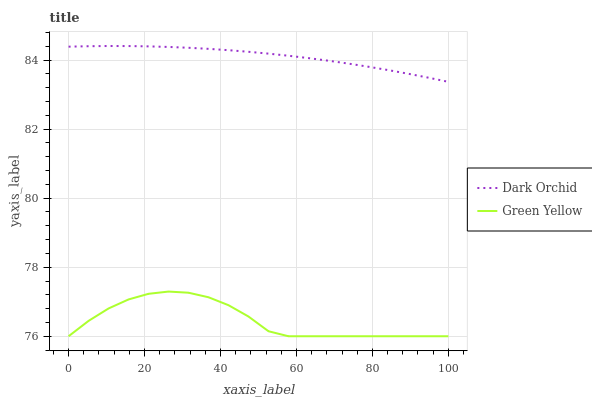Does Green Yellow have the minimum area under the curve?
Answer yes or no. Yes. Does Dark Orchid have the maximum area under the curve?
Answer yes or no. Yes. Does Dark Orchid have the minimum area under the curve?
Answer yes or no. No. Is Dark Orchid the smoothest?
Answer yes or no. Yes. Is Green Yellow the roughest?
Answer yes or no. Yes. Is Dark Orchid the roughest?
Answer yes or no. No. Does Green Yellow have the lowest value?
Answer yes or no. Yes. Does Dark Orchid have the lowest value?
Answer yes or no. No. Does Dark Orchid have the highest value?
Answer yes or no. Yes. Is Green Yellow less than Dark Orchid?
Answer yes or no. Yes. Is Dark Orchid greater than Green Yellow?
Answer yes or no. Yes. Does Green Yellow intersect Dark Orchid?
Answer yes or no. No. 